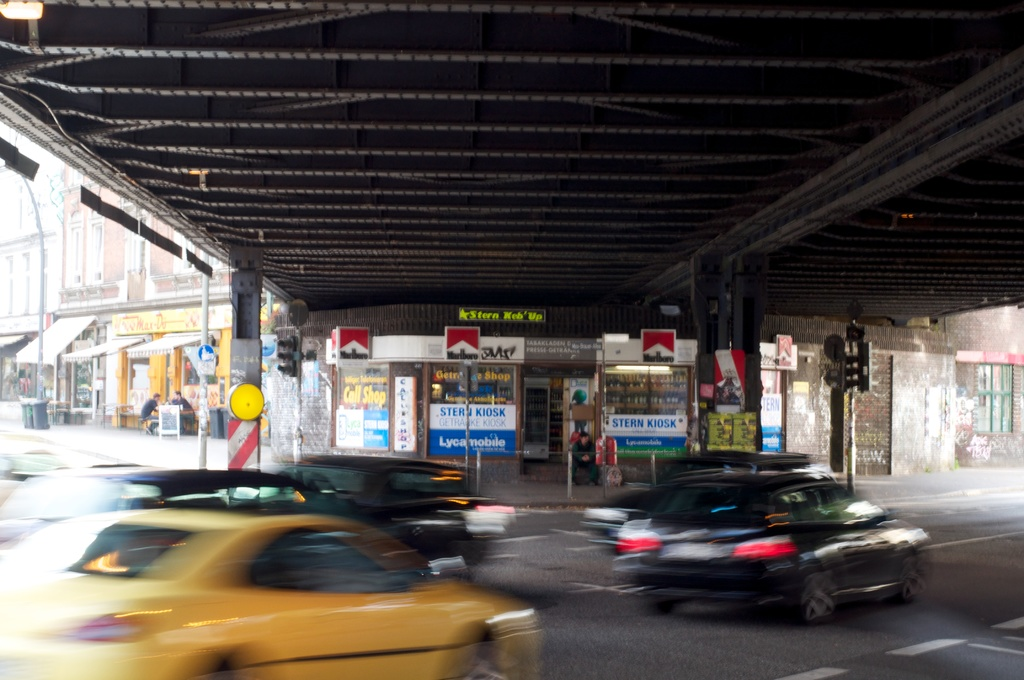How does the traffic condition under the bridge appear? The traffic under the bridge is quite busy with multiple cars captured in motion, indicating a high-traffic area, typical of urban settings. What time of day does it seem to be in the image? Considering the lighting and the shadows, it appears to be either early morning or late afternoon, which are common times for heavier traffic due to commuting. 